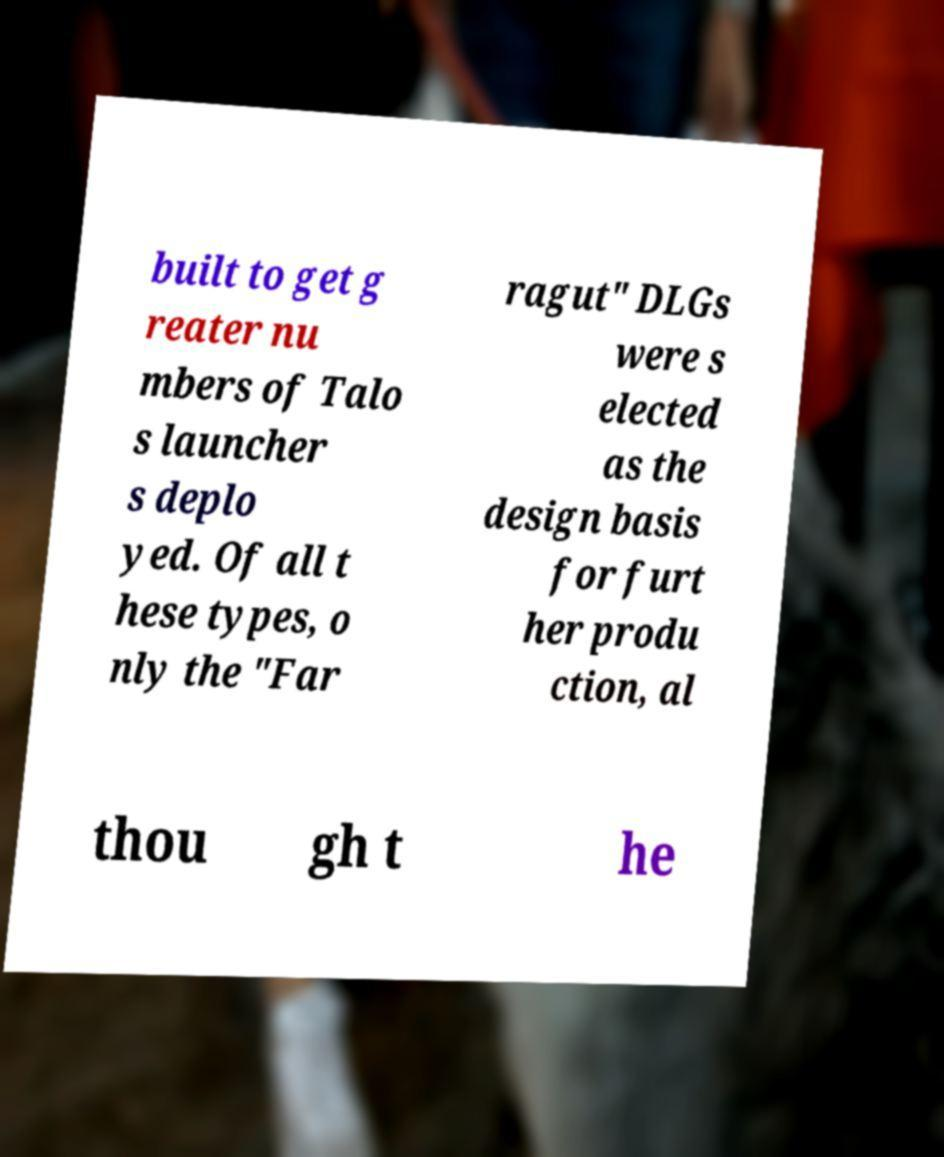What messages or text are displayed in this image? I need them in a readable, typed format. built to get g reater nu mbers of Talo s launcher s deplo yed. Of all t hese types, o nly the "Far ragut" DLGs were s elected as the design basis for furt her produ ction, al thou gh t he 